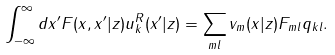<formula> <loc_0><loc_0><loc_500><loc_500>\int ^ { \infty } _ { - \infty } d x ^ { \prime } F ( x , x ^ { \prime } | z ) u ^ { R } _ { k } ( x ^ { \prime } | z ) = \sum _ { m l } v _ { m } ( x | z ) F _ { m l } q _ { k l } .</formula> 